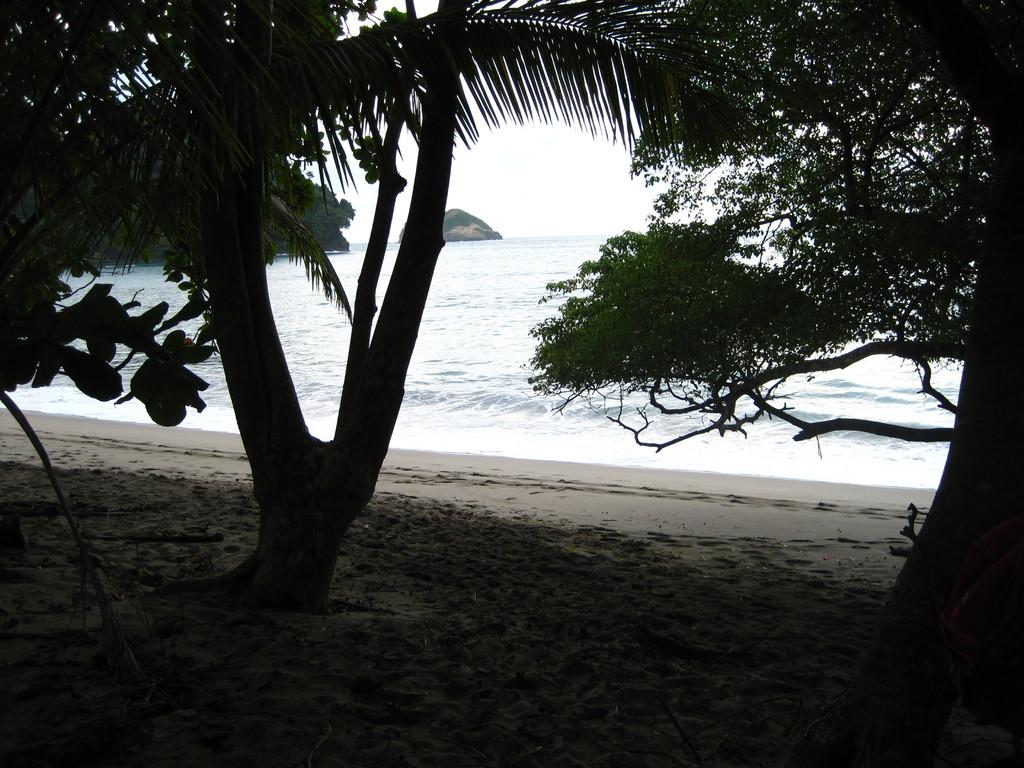What type of terrain is depicted in the image? There is sand in the image. What type of vegetation can be seen in the image? There are trees in the image. What can be seen in the background of the image? There is water, a mountain, and the sky visible in the background of the image. What type of rose can be smelled in the image? There is no rose present in the image, so it cannot be smelled. What type of record can be seen being played in the image? There is no record player or record visible in the image. 